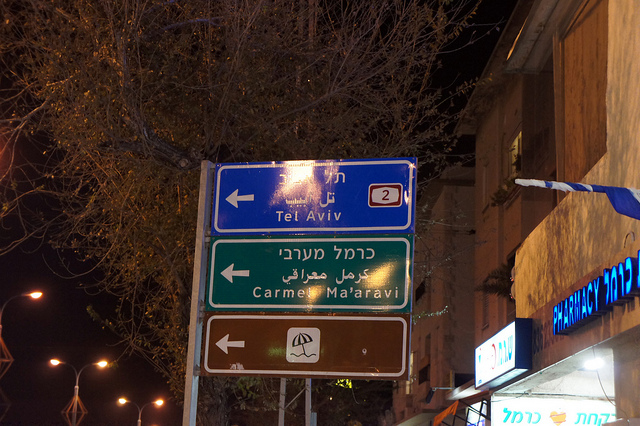<image>What does PRIMACY mean? It is unknown what PRIMACY means. It can refers to pharmacy as well. What does PRIMACY mean? I am not sure what PRIMACY means. It can be interpreted as pharmacy. 